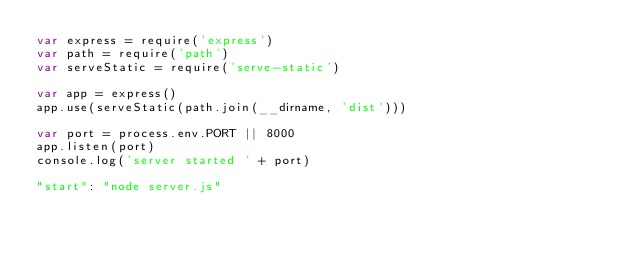Convert code to text. <code><loc_0><loc_0><loc_500><loc_500><_JavaScript_>var express = require('express')
var path = require('path')
var serveStatic = require('serve-static')

var app = express()
app.use(serveStatic(path.join(__dirname, 'dist')))

var port = process.env.PORT || 8000
app.listen(port)
console.log('server started ' + port)

"start": "node server.js"</code> 